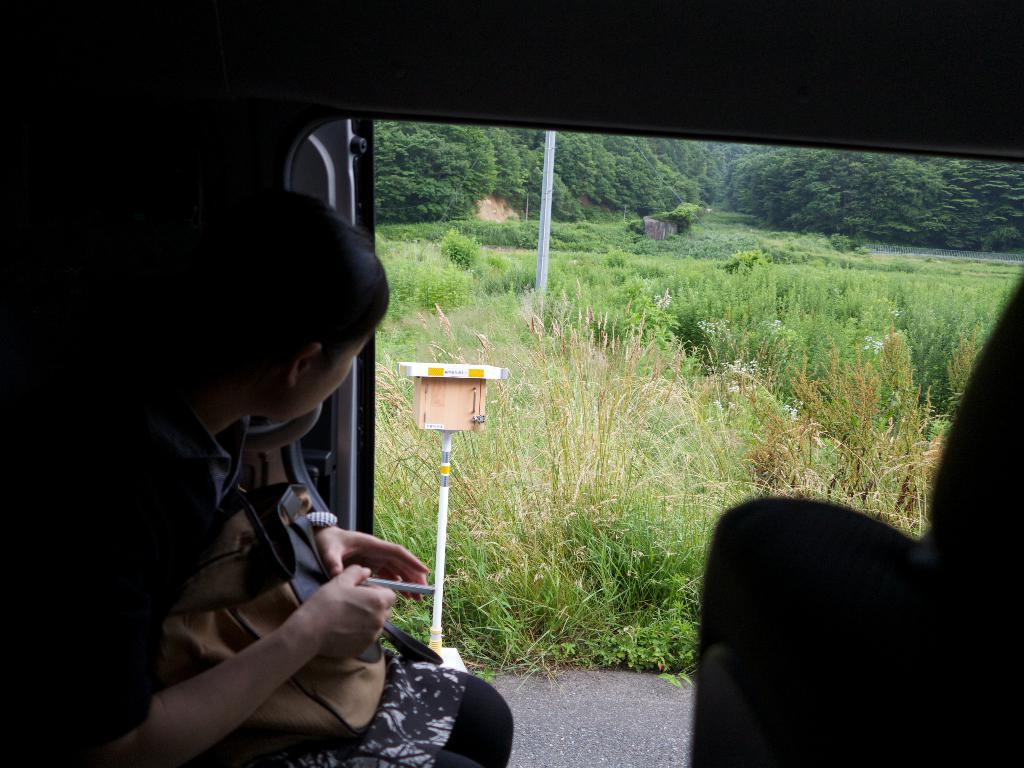What is the lady doing in the image? The lady is sitting on the left side of the image. What is the lady holding in the image? The lady is holding a bag. What can be seen in the background of the image? There is a box with a pole and plants in the background of the image. What type of vegetation is visible in the background of the image? There are trees in the background of the image. What advice does the lady's father give her in the image? There is no father present in the image, and therefore no advice can be given. What type of lawyer is depicted in the image? There is no lawyer present in the image. 